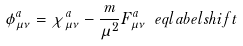<formula> <loc_0><loc_0><loc_500><loc_500>\phi _ { \mu \nu } ^ { a } = \chi _ { \mu \nu } ^ { a } - \frac { m } { \mu ^ { 2 } } F _ { \mu \nu } ^ { a } \ e q l a b e l { s h i f t }</formula> 